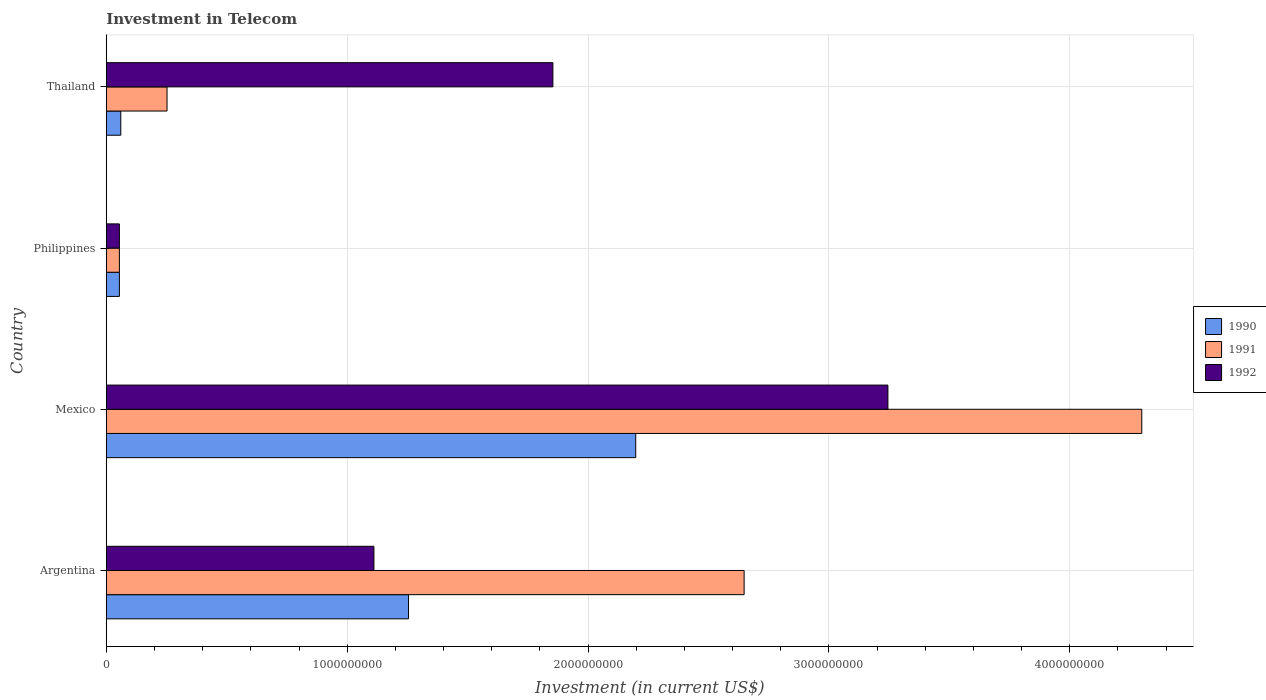How many groups of bars are there?
Give a very brief answer. 4. Are the number of bars on each tick of the Y-axis equal?
Offer a terse response. Yes. How many bars are there on the 4th tick from the top?
Provide a succinct answer. 3. What is the label of the 2nd group of bars from the top?
Keep it short and to the point. Philippines. What is the amount invested in telecom in 1990 in Thailand?
Offer a very short reply. 6.00e+07. Across all countries, what is the maximum amount invested in telecom in 1990?
Offer a terse response. 2.20e+09. Across all countries, what is the minimum amount invested in telecom in 1990?
Give a very brief answer. 5.42e+07. In which country was the amount invested in telecom in 1990 minimum?
Offer a very short reply. Philippines. What is the total amount invested in telecom in 1991 in the graph?
Your answer should be compact. 7.25e+09. What is the difference between the amount invested in telecom in 1990 in Argentina and that in Thailand?
Ensure brevity in your answer.  1.19e+09. What is the difference between the amount invested in telecom in 1991 in Thailand and the amount invested in telecom in 1992 in Philippines?
Give a very brief answer. 1.98e+08. What is the average amount invested in telecom in 1991 per country?
Your answer should be very brief. 1.81e+09. What is the difference between the amount invested in telecom in 1990 and amount invested in telecom in 1992 in Philippines?
Provide a succinct answer. 0. What is the ratio of the amount invested in telecom in 1992 in Argentina to that in Thailand?
Offer a very short reply. 0.6. Is the difference between the amount invested in telecom in 1990 in Argentina and Thailand greater than the difference between the amount invested in telecom in 1992 in Argentina and Thailand?
Ensure brevity in your answer.  Yes. What is the difference between the highest and the second highest amount invested in telecom in 1992?
Keep it short and to the point. 1.39e+09. What is the difference between the highest and the lowest amount invested in telecom in 1991?
Your response must be concise. 4.24e+09. Is the sum of the amount invested in telecom in 1992 in Mexico and Thailand greater than the maximum amount invested in telecom in 1991 across all countries?
Offer a terse response. Yes. How many bars are there?
Offer a terse response. 12. Are all the bars in the graph horizontal?
Provide a short and direct response. Yes. How many countries are there in the graph?
Your response must be concise. 4. What is the difference between two consecutive major ticks on the X-axis?
Keep it short and to the point. 1.00e+09. Does the graph contain any zero values?
Provide a succinct answer. No. How many legend labels are there?
Keep it short and to the point. 3. What is the title of the graph?
Ensure brevity in your answer.  Investment in Telecom. What is the label or title of the X-axis?
Offer a very short reply. Investment (in current US$). What is the Investment (in current US$) in 1990 in Argentina?
Your response must be concise. 1.25e+09. What is the Investment (in current US$) in 1991 in Argentina?
Your response must be concise. 2.65e+09. What is the Investment (in current US$) of 1992 in Argentina?
Your response must be concise. 1.11e+09. What is the Investment (in current US$) of 1990 in Mexico?
Your answer should be very brief. 2.20e+09. What is the Investment (in current US$) of 1991 in Mexico?
Offer a very short reply. 4.30e+09. What is the Investment (in current US$) of 1992 in Mexico?
Provide a short and direct response. 3.24e+09. What is the Investment (in current US$) in 1990 in Philippines?
Offer a very short reply. 5.42e+07. What is the Investment (in current US$) of 1991 in Philippines?
Provide a short and direct response. 5.42e+07. What is the Investment (in current US$) of 1992 in Philippines?
Your answer should be compact. 5.42e+07. What is the Investment (in current US$) in 1990 in Thailand?
Offer a very short reply. 6.00e+07. What is the Investment (in current US$) of 1991 in Thailand?
Give a very brief answer. 2.52e+08. What is the Investment (in current US$) in 1992 in Thailand?
Provide a succinct answer. 1.85e+09. Across all countries, what is the maximum Investment (in current US$) of 1990?
Offer a terse response. 2.20e+09. Across all countries, what is the maximum Investment (in current US$) of 1991?
Offer a very short reply. 4.30e+09. Across all countries, what is the maximum Investment (in current US$) in 1992?
Make the answer very short. 3.24e+09. Across all countries, what is the minimum Investment (in current US$) in 1990?
Ensure brevity in your answer.  5.42e+07. Across all countries, what is the minimum Investment (in current US$) of 1991?
Provide a short and direct response. 5.42e+07. Across all countries, what is the minimum Investment (in current US$) of 1992?
Your answer should be compact. 5.42e+07. What is the total Investment (in current US$) of 1990 in the graph?
Give a very brief answer. 3.57e+09. What is the total Investment (in current US$) of 1991 in the graph?
Provide a short and direct response. 7.25e+09. What is the total Investment (in current US$) in 1992 in the graph?
Your response must be concise. 6.26e+09. What is the difference between the Investment (in current US$) in 1990 in Argentina and that in Mexico?
Keep it short and to the point. -9.43e+08. What is the difference between the Investment (in current US$) in 1991 in Argentina and that in Mexico?
Your response must be concise. -1.65e+09. What is the difference between the Investment (in current US$) of 1992 in Argentina and that in Mexico?
Offer a very short reply. -2.13e+09. What is the difference between the Investment (in current US$) of 1990 in Argentina and that in Philippines?
Offer a very short reply. 1.20e+09. What is the difference between the Investment (in current US$) in 1991 in Argentina and that in Philippines?
Keep it short and to the point. 2.59e+09. What is the difference between the Investment (in current US$) of 1992 in Argentina and that in Philippines?
Give a very brief answer. 1.06e+09. What is the difference between the Investment (in current US$) of 1990 in Argentina and that in Thailand?
Provide a succinct answer. 1.19e+09. What is the difference between the Investment (in current US$) of 1991 in Argentina and that in Thailand?
Offer a terse response. 2.40e+09. What is the difference between the Investment (in current US$) of 1992 in Argentina and that in Thailand?
Offer a terse response. -7.43e+08. What is the difference between the Investment (in current US$) in 1990 in Mexico and that in Philippines?
Make the answer very short. 2.14e+09. What is the difference between the Investment (in current US$) of 1991 in Mexico and that in Philippines?
Your answer should be very brief. 4.24e+09. What is the difference between the Investment (in current US$) in 1992 in Mexico and that in Philippines?
Keep it short and to the point. 3.19e+09. What is the difference between the Investment (in current US$) of 1990 in Mexico and that in Thailand?
Make the answer very short. 2.14e+09. What is the difference between the Investment (in current US$) in 1991 in Mexico and that in Thailand?
Keep it short and to the point. 4.05e+09. What is the difference between the Investment (in current US$) of 1992 in Mexico and that in Thailand?
Give a very brief answer. 1.39e+09. What is the difference between the Investment (in current US$) of 1990 in Philippines and that in Thailand?
Ensure brevity in your answer.  -5.80e+06. What is the difference between the Investment (in current US$) in 1991 in Philippines and that in Thailand?
Give a very brief answer. -1.98e+08. What is the difference between the Investment (in current US$) in 1992 in Philippines and that in Thailand?
Offer a very short reply. -1.80e+09. What is the difference between the Investment (in current US$) in 1990 in Argentina and the Investment (in current US$) in 1991 in Mexico?
Your answer should be compact. -3.04e+09. What is the difference between the Investment (in current US$) in 1990 in Argentina and the Investment (in current US$) in 1992 in Mexico?
Your answer should be very brief. -1.99e+09. What is the difference between the Investment (in current US$) of 1991 in Argentina and the Investment (in current US$) of 1992 in Mexico?
Ensure brevity in your answer.  -5.97e+08. What is the difference between the Investment (in current US$) in 1990 in Argentina and the Investment (in current US$) in 1991 in Philippines?
Your response must be concise. 1.20e+09. What is the difference between the Investment (in current US$) of 1990 in Argentina and the Investment (in current US$) of 1992 in Philippines?
Offer a very short reply. 1.20e+09. What is the difference between the Investment (in current US$) of 1991 in Argentina and the Investment (in current US$) of 1992 in Philippines?
Your answer should be compact. 2.59e+09. What is the difference between the Investment (in current US$) in 1990 in Argentina and the Investment (in current US$) in 1991 in Thailand?
Keep it short and to the point. 1.00e+09. What is the difference between the Investment (in current US$) in 1990 in Argentina and the Investment (in current US$) in 1992 in Thailand?
Make the answer very short. -5.99e+08. What is the difference between the Investment (in current US$) of 1991 in Argentina and the Investment (in current US$) of 1992 in Thailand?
Your answer should be compact. 7.94e+08. What is the difference between the Investment (in current US$) of 1990 in Mexico and the Investment (in current US$) of 1991 in Philippines?
Offer a very short reply. 2.14e+09. What is the difference between the Investment (in current US$) of 1990 in Mexico and the Investment (in current US$) of 1992 in Philippines?
Your response must be concise. 2.14e+09. What is the difference between the Investment (in current US$) of 1991 in Mexico and the Investment (in current US$) of 1992 in Philippines?
Provide a succinct answer. 4.24e+09. What is the difference between the Investment (in current US$) of 1990 in Mexico and the Investment (in current US$) of 1991 in Thailand?
Your answer should be very brief. 1.95e+09. What is the difference between the Investment (in current US$) of 1990 in Mexico and the Investment (in current US$) of 1992 in Thailand?
Offer a very short reply. 3.44e+08. What is the difference between the Investment (in current US$) of 1991 in Mexico and the Investment (in current US$) of 1992 in Thailand?
Give a very brief answer. 2.44e+09. What is the difference between the Investment (in current US$) in 1990 in Philippines and the Investment (in current US$) in 1991 in Thailand?
Your response must be concise. -1.98e+08. What is the difference between the Investment (in current US$) of 1990 in Philippines and the Investment (in current US$) of 1992 in Thailand?
Make the answer very short. -1.80e+09. What is the difference between the Investment (in current US$) of 1991 in Philippines and the Investment (in current US$) of 1992 in Thailand?
Offer a terse response. -1.80e+09. What is the average Investment (in current US$) in 1990 per country?
Your answer should be very brief. 8.92e+08. What is the average Investment (in current US$) of 1991 per country?
Your answer should be compact. 1.81e+09. What is the average Investment (in current US$) of 1992 per country?
Keep it short and to the point. 1.57e+09. What is the difference between the Investment (in current US$) in 1990 and Investment (in current US$) in 1991 in Argentina?
Offer a very short reply. -1.39e+09. What is the difference between the Investment (in current US$) of 1990 and Investment (in current US$) of 1992 in Argentina?
Make the answer very short. 1.44e+08. What is the difference between the Investment (in current US$) of 1991 and Investment (in current US$) of 1992 in Argentina?
Ensure brevity in your answer.  1.54e+09. What is the difference between the Investment (in current US$) of 1990 and Investment (in current US$) of 1991 in Mexico?
Ensure brevity in your answer.  -2.10e+09. What is the difference between the Investment (in current US$) of 1990 and Investment (in current US$) of 1992 in Mexico?
Provide a short and direct response. -1.05e+09. What is the difference between the Investment (in current US$) in 1991 and Investment (in current US$) in 1992 in Mexico?
Provide a short and direct response. 1.05e+09. What is the difference between the Investment (in current US$) of 1991 and Investment (in current US$) of 1992 in Philippines?
Provide a succinct answer. 0. What is the difference between the Investment (in current US$) in 1990 and Investment (in current US$) in 1991 in Thailand?
Your response must be concise. -1.92e+08. What is the difference between the Investment (in current US$) in 1990 and Investment (in current US$) in 1992 in Thailand?
Make the answer very short. -1.79e+09. What is the difference between the Investment (in current US$) of 1991 and Investment (in current US$) of 1992 in Thailand?
Your answer should be very brief. -1.60e+09. What is the ratio of the Investment (in current US$) in 1990 in Argentina to that in Mexico?
Offer a very short reply. 0.57. What is the ratio of the Investment (in current US$) in 1991 in Argentina to that in Mexico?
Ensure brevity in your answer.  0.62. What is the ratio of the Investment (in current US$) of 1992 in Argentina to that in Mexico?
Offer a very short reply. 0.34. What is the ratio of the Investment (in current US$) in 1990 in Argentina to that in Philippines?
Ensure brevity in your answer.  23.15. What is the ratio of the Investment (in current US$) in 1991 in Argentina to that in Philippines?
Offer a terse response. 48.86. What is the ratio of the Investment (in current US$) in 1992 in Argentina to that in Philippines?
Your response must be concise. 20.5. What is the ratio of the Investment (in current US$) in 1990 in Argentina to that in Thailand?
Your response must be concise. 20.91. What is the ratio of the Investment (in current US$) in 1991 in Argentina to that in Thailand?
Offer a very short reply. 10.51. What is the ratio of the Investment (in current US$) in 1992 in Argentina to that in Thailand?
Provide a succinct answer. 0.6. What is the ratio of the Investment (in current US$) of 1990 in Mexico to that in Philippines?
Your answer should be very brief. 40.55. What is the ratio of the Investment (in current US$) in 1991 in Mexico to that in Philippines?
Offer a terse response. 79.32. What is the ratio of the Investment (in current US$) in 1992 in Mexico to that in Philippines?
Make the answer very short. 59.87. What is the ratio of the Investment (in current US$) of 1990 in Mexico to that in Thailand?
Your response must be concise. 36.63. What is the ratio of the Investment (in current US$) in 1991 in Mexico to that in Thailand?
Your answer should be compact. 17.06. What is the ratio of the Investment (in current US$) in 1992 in Mexico to that in Thailand?
Your answer should be compact. 1.75. What is the ratio of the Investment (in current US$) in 1990 in Philippines to that in Thailand?
Offer a very short reply. 0.9. What is the ratio of the Investment (in current US$) in 1991 in Philippines to that in Thailand?
Provide a succinct answer. 0.22. What is the ratio of the Investment (in current US$) in 1992 in Philippines to that in Thailand?
Give a very brief answer. 0.03. What is the difference between the highest and the second highest Investment (in current US$) in 1990?
Keep it short and to the point. 9.43e+08. What is the difference between the highest and the second highest Investment (in current US$) of 1991?
Give a very brief answer. 1.65e+09. What is the difference between the highest and the second highest Investment (in current US$) in 1992?
Your answer should be very brief. 1.39e+09. What is the difference between the highest and the lowest Investment (in current US$) in 1990?
Ensure brevity in your answer.  2.14e+09. What is the difference between the highest and the lowest Investment (in current US$) of 1991?
Your answer should be very brief. 4.24e+09. What is the difference between the highest and the lowest Investment (in current US$) in 1992?
Your response must be concise. 3.19e+09. 